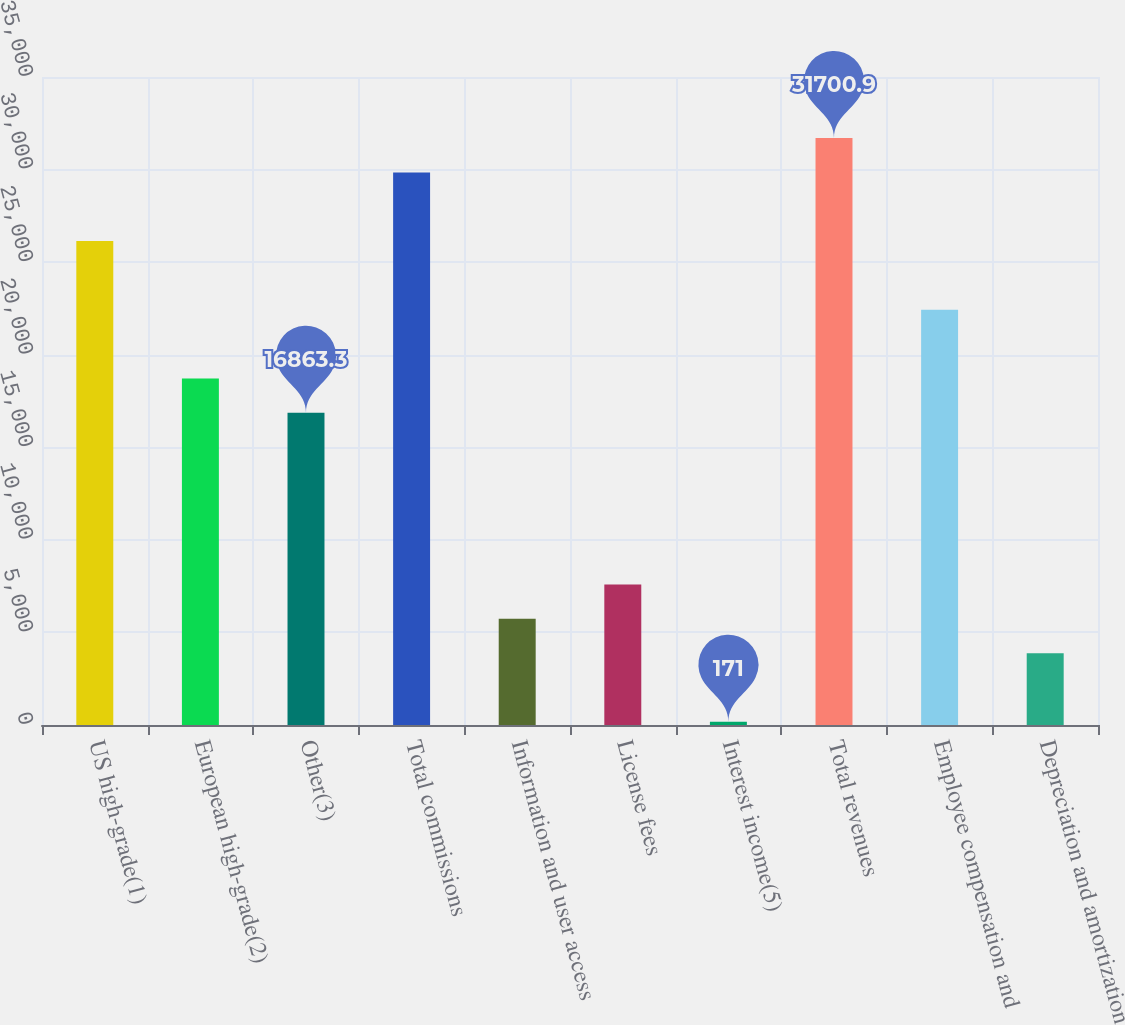Convert chart to OTSL. <chart><loc_0><loc_0><loc_500><loc_500><bar_chart><fcel>US high-grade(1)<fcel>European high-grade(2)<fcel>Other(3)<fcel>Total commissions<fcel>Information and user access<fcel>License fees<fcel>Interest income(5)<fcel>Total revenues<fcel>Employee compensation and<fcel>Depreciation and amortization<nl><fcel>26136.8<fcel>18718<fcel>16863.3<fcel>29846.2<fcel>5735.1<fcel>7589.8<fcel>171<fcel>31700.9<fcel>22427.4<fcel>3880.4<nl></chart> 